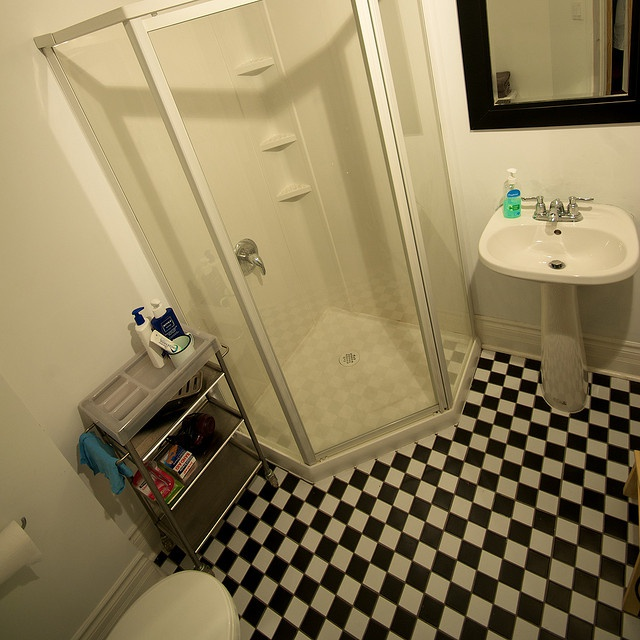Describe the objects in this image and their specific colors. I can see sink in tan and olive tones, toilet in tan and olive tones, cup in tan, black, and gray tones, and bottle in tan, lightgreen, turquoise, and teal tones in this image. 